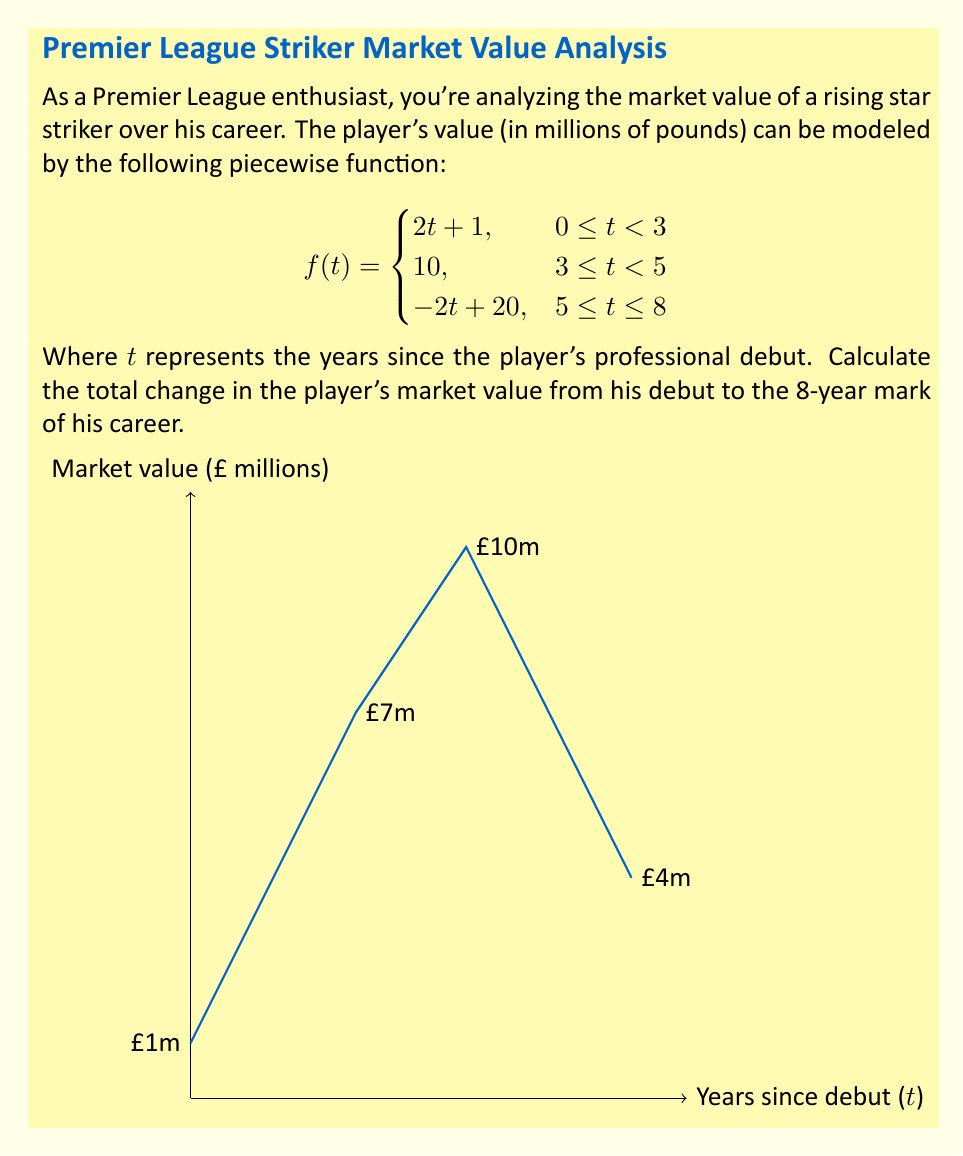Help me with this question. Let's approach this step-by-step:

1) First, we need to calculate the player's value at the start of his career (t = 0) and at the 8-year mark (t = 8).

2) At t = 0 (debut):
   $f(0) = 2(0) + 1 = 1$ million pounds

3) At t = 8:
   $f(8) = -2(8) + 20 = 4$ million pounds

4) The total change in value is the difference between these two points:
   $\text{Change} = f(8) - f(0) = 4 - 1 = 3$ million pounds

5) However, we need to be careful. This doesn't represent the full picture of the player's value changes over time.

6) To get a more accurate result, let's examine the critical points of the piecewise function:

   At t = 3: $f(3) = 2(3) + 1 = 7$ million pounds
   At t = 5: $f(5) = 10$ million pounds

7) Now we can calculate the total change by summing the increases and decreases:
   
   0 to 3 years: Increase of $7 - 1 = 6$ million
   3 to 5 years: Increase of $10 - 7 = 3$ million
   5 to 8 years: Decrease of $4 - 10 = -6$ million

8) The total change is the sum of these changes:
   $\text{Total Change} = 6 + 3 + (-6) = 3$ million pounds

This matches our initial calculation, but provides a more comprehensive understanding of the value fluctuations over time.
Answer: £3 million 